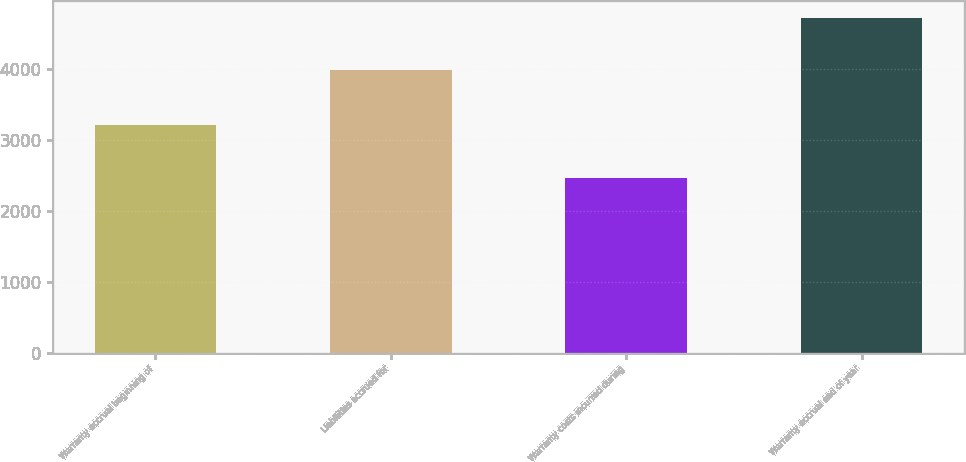<chart> <loc_0><loc_0><loc_500><loc_500><bar_chart><fcel>Warranty accrual beginning of<fcel>Liabilities accrued for<fcel>Warranty costs incurred during<fcel>Warranty accrual end of year<nl><fcel>3204<fcel>3973<fcel>2459<fcel>4718<nl></chart> 